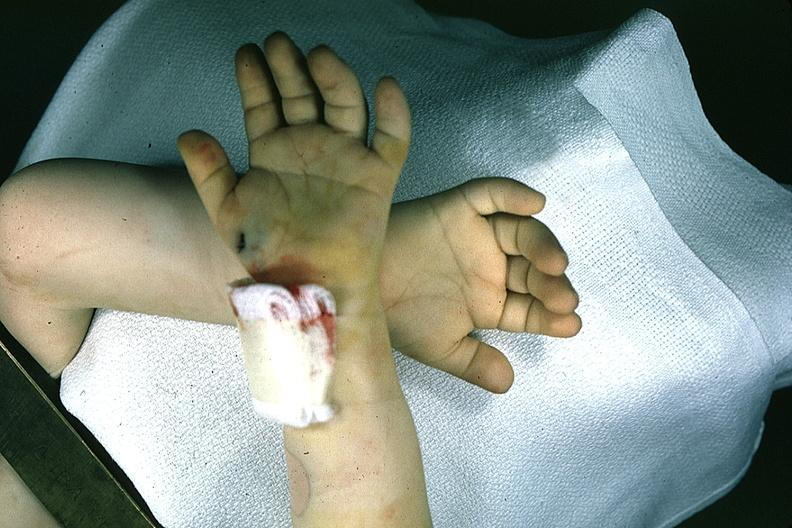what does this image show?
Answer the question using a single word or phrase. Hands one with simian crease 